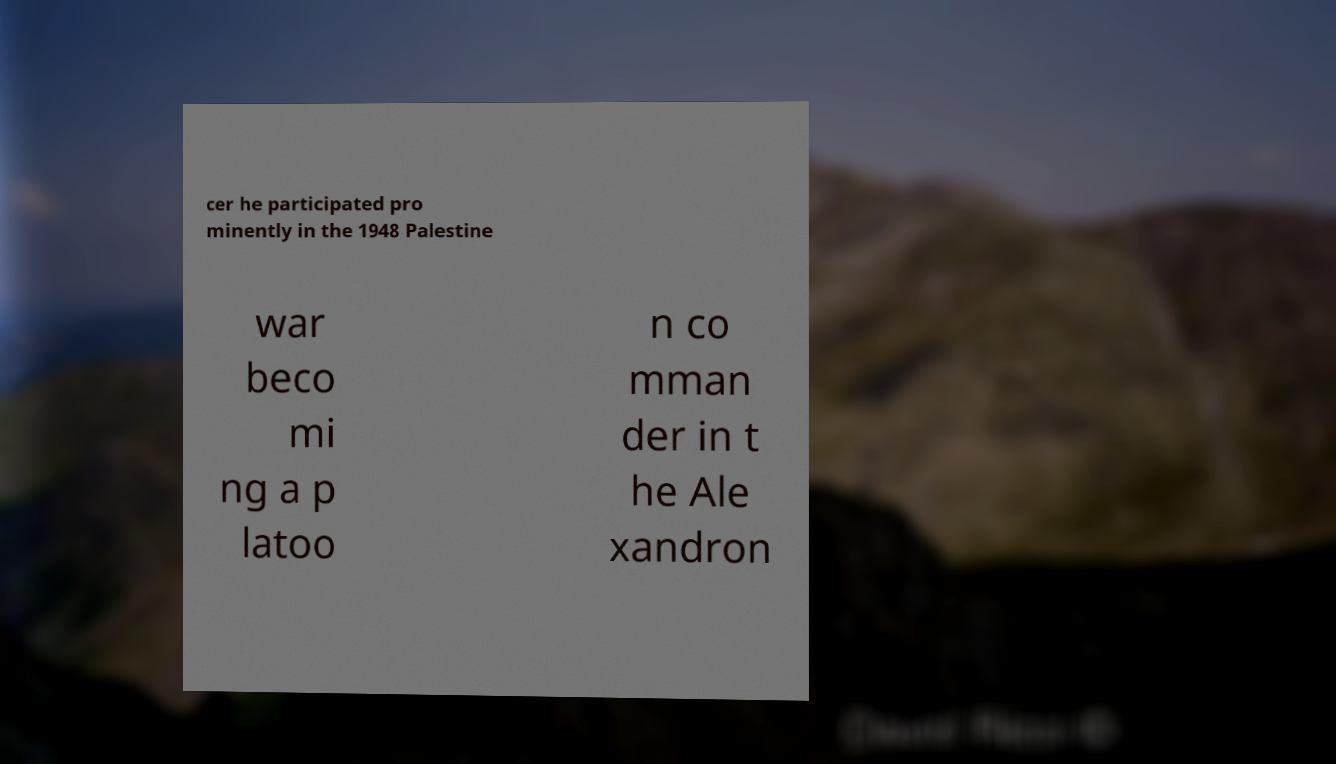Could you assist in decoding the text presented in this image and type it out clearly? cer he participated pro minently in the 1948 Palestine war beco mi ng a p latoo n co mman der in t he Ale xandron 